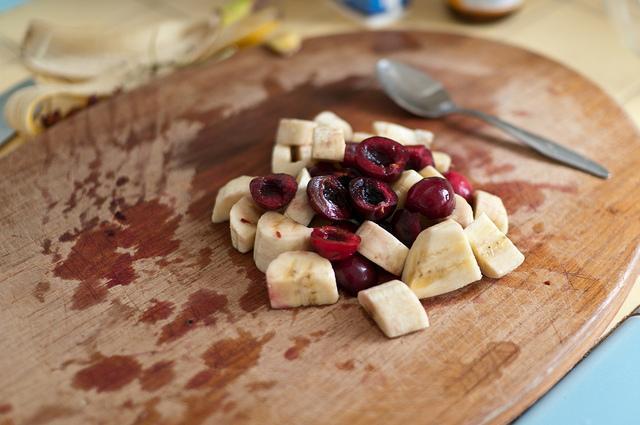How many bananas can you see?
Give a very brief answer. 2. How many spoons are there?
Give a very brief answer. 1. How many people are sitting on chair?
Give a very brief answer. 0. 